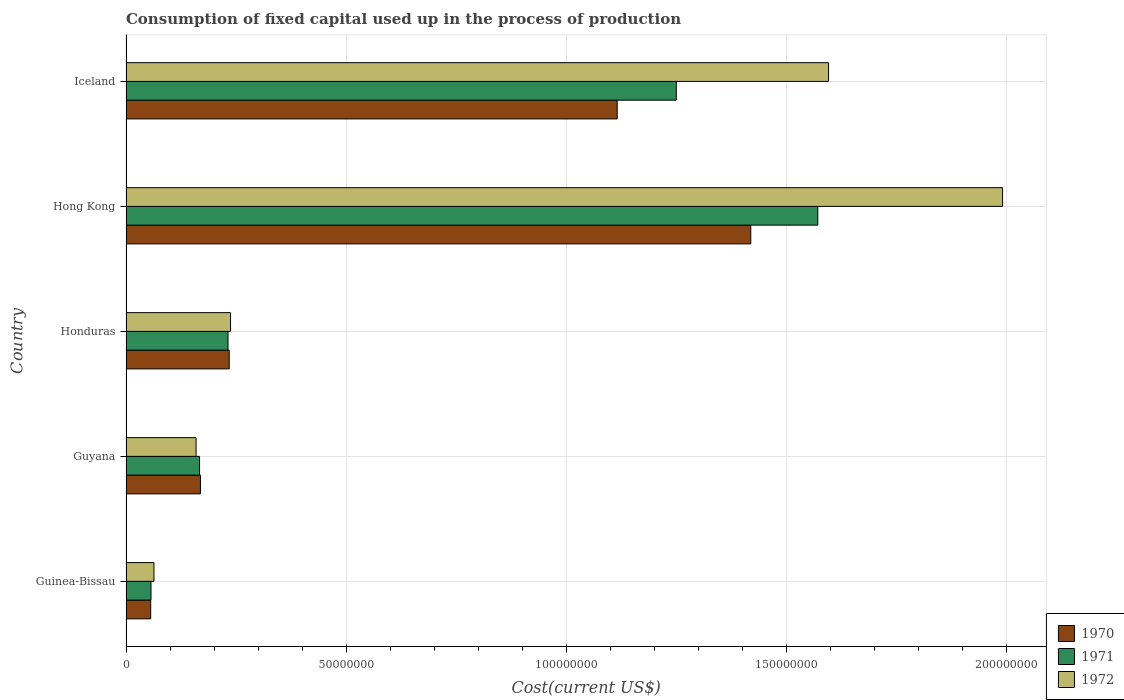How many groups of bars are there?
Your response must be concise. 5. Are the number of bars per tick equal to the number of legend labels?
Ensure brevity in your answer.  Yes. Are the number of bars on each tick of the Y-axis equal?
Give a very brief answer. Yes. How many bars are there on the 5th tick from the top?
Your answer should be compact. 3. What is the label of the 5th group of bars from the top?
Your answer should be very brief. Guinea-Bissau. What is the amount consumed in the process of production in 1972 in Guinea-Bissau?
Keep it short and to the point. 6.34e+06. Across all countries, what is the maximum amount consumed in the process of production in 1970?
Offer a very short reply. 1.42e+08. Across all countries, what is the minimum amount consumed in the process of production in 1972?
Offer a terse response. 6.34e+06. In which country was the amount consumed in the process of production in 1972 maximum?
Ensure brevity in your answer.  Hong Kong. In which country was the amount consumed in the process of production in 1971 minimum?
Offer a terse response. Guinea-Bissau. What is the total amount consumed in the process of production in 1970 in the graph?
Your response must be concise. 2.99e+08. What is the difference between the amount consumed in the process of production in 1970 in Honduras and that in Hong Kong?
Make the answer very short. -1.18e+08. What is the difference between the amount consumed in the process of production in 1972 in Hong Kong and the amount consumed in the process of production in 1970 in Iceland?
Your answer should be very brief. 8.75e+07. What is the average amount consumed in the process of production in 1970 per country?
Offer a very short reply. 5.99e+07. What is the difference between the amount consumed in the process of production in 1972 and amount consumed in the process of production in 1971 in Honduras?
Your answer should be very brief. 5.73e+05. What is the ratio of the amount consumed in the process of production in 1972 in Guinea-Bissau to that in Guyana?
Your response must be concise. 0.4. What is the difference between the highest and the second highest amount consumed in the process of production in 1970?
Provide a succinct answer. 3.03e+07. What is the difference between the highest and the lowest amount consumed in the process of production in 1970?
Offer a terse response. 1.36e+08. In how many countries, is the amount consumed in the process of production in 1971 greater than the average amount consumed in the process of production in 1971 taken over all countries?
Offer a terse response. 2. Is the sum of the amount consumed in the process of production in 1971 in Guyana and Iceland greater than the maximum amount consumed in the process of production in 1970 across all countries?
Give a very brief answer. No. What does the 1st bar from the bottom in Iceland represents?
Offer a terse response. 1970. Are all the bars in the graph horizontal?
Ensure brevity in your answer.  Yes. How many countries are there in the graph?
Your answer should be compact. 5. What is the difference between two consecutive major ticks on the X-axis?
Provide a succinct answer. 5.00e+07. Are the values on the major ticks of X-axis written in scientific E-notation?
Your answer should be very brief. No. Does the graph contain any zero values?
Make the answer very short. No. Does the graph contain grids?
Your response must be concise. Yes. Where does the legend appear in the graph?
Keep it short and to the point. Bottom right. How many legend labels are there?
Your answer should be very brief. 3. What is the title of the graph?
Your answer should be very brief. Consumption of fixed capital used up in the process of production. Does "1969" appear as one of the legend labels in the graph?
Provide a short and direct response. No. What is the label or title of the X-axis?
Your response must be concise. Cost(current US$). What is the Cost(current US$) of 1970 in Guinea-Bissau?
Provide a succinct answer. 5.61e+06. What is the Cost(current US$) of 1971 in Guinea-Bissau?
Make the answer very short. 5.67e+06. What is the Cost(current US$) in 1972 in Guinea-Bissau?
Provide a succinct answer. 6.34e+06. What is the Cost(current US$) of 1970 in Guyana?
Your answer should be compact. 1.69e+07. What is the Cost(current US$) of 1971 in Guyana?
Give a very brief answer. 1.67e+07. What is the Cost(current US$) of 1972 in Guyana?
Keep it short and to the point. 1.59e+07. What is the Cost(current US$) in 1970 in Honduras?
Ensure brevity in your answer.  2.34e+07. What is the Cost(current US$) in 1971 in Honduras?
Offer a very short reply. 2.32e+07. What is the Cost(current US$) in 1972 in Honduras?
Keep it short and to the point. 2.37e+07. What is the Cost(current US$) of 1970 in Hong Kong?
Offer a terse response. 1.42e+08. What is the Cost(current US$) in 1971 in Hong Kong?
Offer a very short reply. 1.57e+08. What is the Cost(current US$) in 1972 in Hong Kong?
Your answer should be very brief. 1.99e+08. What is the Cost(current US$) in 1970 in Iceland?
Provide a short and direct response. 1.12e+08. What is the Cost(current US$) in 1971 in Iceland?
Offer a very short reply. 1.25e+08. What is the Cost(current US$) of 1972 in Iceland?
Offer a very short reply. 1.60e+08. Across all countries, what is the maximum Cost(current US$) of 1970?
Your response must be concise. 1.42e+08. Across all countries, what is the maximum Cost(current US$) in 1971?
Your answer should be compact. 1.57e+08. Across all countries, what is the maximum Cost(current US$) of 1972?
Provide a succinct answer. 1.99e+08. Across all countries, what is the minimum Cost(current US$) in 1970?
Your response must be concise. 5.61e+06. Across all countries, what is the minimum Cost(current US$) of 1971?
Ensure brevity in your answer.  5.67e+06. Across all countries, what is the minimum Cost(current US$) in 1972?
Keep it short and to the point. 6.34e+06. What is the total Cost(current US$) of 1970 in the graph?
Your answer should be very brief. 2.99e+08. What is the total Cost(current US$) of 1971 in the graph?
Your answer should be compact. 3.28e+08. What is the total Cost(current US$) in 1972 in the graph?
Ensure brevity in your answer.  4.05e+08. What is the difference between the Cost(current US$) of 1970 in Guinea-Bissau and that in Guyana?
Offer a very short reply. -1.13e+07. What is the difference between the Cost(current US$) in 1971 in Guinea-Bissau and that in Guyana?
Ensure brevity in your answer.  -1.10e+07. What is the difference between the Cost(current US$) of 1972 in Guinea-Bissau and that in Guyana?
Make the answer very short. -9.56e+06. What is the difference between the Cost(current US$) in 1970 in Guinea-Bissau and that in Honduras?
Provide a short and direct response. -1.78e+07. What is the difference between the Cost(current US$) in 1971 in Guinea-Bissau and that in Honduras?
Your answer should be compact. -1.75e+07. What is the difference between the Cost(current US$) in 1972 in Guinea-Bissau and that in Honduras?
Ensure brevity in your answer.  -1.74e+07. What is the difference between the Cost(current US$) of 1970 in Guinea-Bissau and that in Hong Kong?
Provide a succinct answer. -1.36e+08. What is the difference between the Cost(current US$) of 1971 in Guinea-Bissau and that in Hong Kong?
Keep it short and to the point. -1.51e+08. What is the difference between the Cost(current US$) in 1972 in Guinea-Bissau and that in Hong Kong?
Your response must be concise. -1.93e+08. What is the difference between the Cost(current US$) of 1970 in Guinea-Bissau and that in Iceland?
Provide a short and direct response. -1.06e+08. What is the difference between the Cost(current US$) of 1971 in Guinea-Bissau and that in Iceland?
Your answer should be compact. -1.19e+08. What is the difference between the Cost(current US$) of 1972 in Guinea-Bissau and that in Iceland?
Give a very brief answer. -1.53e+08. What is the difference between the Cost(current US$) in 1970 in Guyana and that in Honduras?
Your answer should be compact. -6.54e+06. What is the difference between the Cost(current US$) in 1971 in Guyana and that in Honduras?
Make the answer very short. -6.46e+06. What is the difference between the Cost(current US$) in 1972 in Guyana and that in Honduras?
Give a very brief answer. -7.83e+06. What is the difference between the Cost(current US$) of 1970 in Guyana and that in Hong Kong?
Give a very brief answer. -1.25e+08. What is the difference between the Cost(current US$) in 1971 in Guyana and that in Hong Kong?
Offer a very short reply. -1.40e+08. What is the difference between the Cost(current US$) in 1972 in Guyana and that in Hong Kong?
Your response must be concise. -1.83e+08. What is the difference between the Cost(current US$) in 1970 in Guyana and that in Iceland?
Your answer should be compact. -9.46e+07. What is the difference between the Cost(current US$) in 1971 in Guyana and that in Iceland?
Offer a terse response. -1.08e+08. What is the difference between the Cost(current US$) of 1972 in Guyana and that in Iceland?
Provide a succinct answer. -1.44e+08. What is the difference between the Cost(current US$) of 1970 in Honduras and that in Hong Kong?
Provide a succinct answer. -1.18e+08. What is the difference between the Cost(current US$) in 1971 in Honduras and that in Hong Kong?
Your answer should be very brief. -1.34e+08. What is the difference between the Cost(current US$) of 1972 in Honduras and that in Hong Kong?
Offer a very short reply. -1.75e+08. What is the difference between the Cost(current US$) of 1970 in Honduras and that in Iceland?
Make the answer very short. -8.81e+07. What is the difference between the Cost(current US$) in 1971 in Honduras and that in Iceland?
Offer a terse response. -1.02e+08. What is the difference between the Cost(current US$) of 1972 in Honduras and that in Iceland?
Give a very brief answer. -1.36e+08. What is the difference between the Cost(current US$) in 1970 in Hong Kong and that in Iceland?
Provide a succinct answer. 3.03e+07. What is the difference between the Cost(current US$) of 1971 in Hong Kong and that in Iceland?
Your response must be concise. 3.21e+07. What is the difference between the Cost(current US$) in 1972 in Hong Kong and that in Iceland?
Provide a succinct answer. 3.95e+07. What is the difference between the Cost(current US$) of 1970 in Guinea-Bissau and the Cost(current US$) of 1971 in Guyana?
Keep it short and to the point. -1.11e+07. What is the difference between the Cost(current US$) of 1970 in Guinea-Bissau and the Cost(current US$) of 1972 in Guyana?
Ensure brevity in your answer.  -1.03e+07. What is the difference between the Cost(current US$) in 1971 in Guinea-Bissau and the Cost(current US$) in 1972 in Guyana?
Make the answer very short. -1.02e+07. What is the difference between the Cost(current US$) of 1970 in Guinea-Bissau and the Cost(current US$) of 1971 in Honduras?
Your answer should be compact. -1.76e+07. What is the difference between the Cost(current US$) in 1970 in Guinea-Bissau and the Cost(current US$) in 1972 in Honduras?
Ensure brevity in your answer.  -1.81e+07. What is the difference between the Cost(current US$) of 1971 in Guinea-Bissau and the Cost(current US$) of 1972 in Honduras?
Your answer should be compact. -1.81e+07. What is the difference between the Cost(current US$) of 1970 in Guinea-Bissau and the Cost(current US$) of 1971 in Hong Kong?
Keep it short and to the point. -1.51e+08. What is the difference between the Cost(current US$) in 1970 in Guinea-Bissau and the Cost(current US$) in 1972 in Hong Kong?
Provide a short and direct response. -1.93e+08. What is the difference between the Cost(current US$) in 1971 in Guinea-Bissau and the Cost(current US$) in 1972 in Hong Kong?
Keep it short and to the point. -1.93e+08. What is the difference between the Cost(current US$) of 1970 in Guinea-Bissau and the Cost(current US$) of 1971 in Iceland?
Your response must be concise. -1.19e+08. What is the difference between the Cost(current US$) of 1970 in Guinea-Bissau and the Cost(current US$) of 1972 in Iceland?
Offer a terse response. -1.54e+08. What is the difference between the Cost(current US$) of 1971 in Guinea-Bissau and the Cost(current US$) of 1972 in Iceland?
Ensure brevity in your answer.  -1.54e+08. What is the difference between the Cost(current US$) of 1970 in Guyana and the Cost(current US$) of 1971 in Honduras?
Give a very brief answer. -6.26e+06. What is the difference between the Cost(current US$) in 1970 in Guyana and the Cost(current US$) in 1972 in Honduras?
Ensure brevity in your answer.  -6.83e+06. What is the difference between the Cost(current US$) in 1971 in Guyana and the Cost(current US$) in 1972 in Honduras?
Your response must be concise. -7.03e+06. What is the difference between the Cost(current US$) of 1970 in Guyana and the Cost(current US$) of 1971 in Hong Kong?
Provide a succinct answer. -1.40e+08. What is the difference between the Cost(current US$) in 1970 in Guyana and the Cost(current US$) in 1972 in Hong Kong?
Your answer should be compact. -1.82e+08. What is the difference between the Cost(current US$) in 1971 in Guyana and the Cost(current US$) in 1972 in Hong Kong?
Offer a very short reply. -1.82e+08. What is the difference between the Cost(current US$) in 1970 in Guyana and the Cost(current US$) in 1971 in Iceland?
Keep it short and to the point. -1.08e+08. What is the difference between the Cost(current US$) in 1970 in Guyana and the Cost(current US$) in 1972 in Iceland?
Give a very brief answer. -1.43e+08. What is the difference between the Cost(current US$) in 1971 in Guyana and the Cost(current US$) in 1972 in Iceland?
Your answer should be compact. -1.43e+08. What is the difference between the Cost(current US$) in 1970 in Honduras and the Cost(current US$) in 1971 in Hong Kong?
Make the answer very short. -1.34e+08. What is the difference between the Cost(current US$) of 1970 in Honduras and the Cost(current US$) of 1972 in Hong Kong?
Keep it short and to the point. -1.76e+08. What is the difference between the Cost(current US$) of 1971 in Honduras and the Cost(current US$) of 1972 in Hong Kong?
Provide a short and direct response. -1.76e+08. What is the difference between the Cost(current US$) of 1970 in Honduras and the Cost(current US$) of 1971 in Iceland?
Your answer should be compact. -1.02e+08. What is the difference between the Cost(current US$) in 1970 in Honduras and the Cost(current US$) in 1972 in Iceland?
Provide a succinct answer. -1.36e+08. What is the difference between the Cost(current US$) in 1971 in Honduras and the Cost(current US$) in 1972 in Iceland?
Provide a succinct answer. -1.36e+08. What is the difference between the Cost(current US$) in 1970 in Hong Kong and the Cost(current US$) in 1971 in Iceland?
Make the answer very short. 1.69e+07. What is the difference between the Cost(current US$) of 1970 in Hong Kong and the Cost(current US$) of 1972 in Iceland?
Your response must be concise. -1.77e+07. What is the difference between the Cost(current US$) of 1971 in Hong Kong and the Cost(current US$) of 1972 in Iceland?
Give a very brief answer. -2.45e+06. What is the average Cost(current US$) in 1970 per country?
Provide a succinct answer. 5.99e+07. What is the average Cost(current US$) in 1971 per country?
Your answer should be very brief. 6.55e+07. What is the average Cost(current US$) of 1972 per country?
Offer a terse response. 8.09e+07. What is the difference between the Cost(current US$) of 1970 and Cost(current US$) of 1971 in Guinea-Bissau?
Keep it short and to the point. -6.59e+04. What is the difference between the Cost(current US$) in 1970 and Cost(current US$) in 1972 in Guinea-Bissau?
Provide a succinct answer. -7.37e+05. What is the difference between the Cost(current US$) in 1971 and Cost(current US$) in 1972 in Guinea-Bissau?
Keep it short and to the point. -6.71e+05. What is the difference between the Cost(current US$) of 1970 and Cost(current US$) of 1972 in Guyana?
Provide a short and direct response. 9.95e+05. What is the difference between the Cost(current US$) in 1971 and Cost(current US$) in 1972 in Guyana?
Keep it short and to the point. 7.95e+05. What is the difference between the Cost(current US$) in 1970 and Cost(current US$) in 1971 in Honduras?
Ensure brevity in your answer.  2.75e+05. What is the difference between the Cost(current US$) of 1970 and Cost(current US$) of 1972 in Honduras?
Make the answer very short. -2.98e+05. What is the difference between the Cost(current US$) in 1971 and Cost(current US$) in 1972 in Honduras?
Make the answer very short. -5.73e+05. What is the difference between the Cost(current US$) of 1970 and Cost(current US$) of 1971 in Hong Kong?
Provide a succinct answer. -1.52e+07. What is the difference between the Cost(current US$) of 1970 and Cost(current US$) of 1972 in Hong Kong?
Offer a very short reply. -5.72e+07. What is the difference between the Cost(current US$) of 1971 and Cost(current US$) of 1972 in Hong Kong?
Your answer should be very brief. -4.20e+07. What is the difference between the Cost(current US$) of 1970 and Cost(current US$) of 1971 in Iceland?
Provide a short and direct response. -1.34e+07. What is the difference between the Cost(current US$) in 1970 and Cost(current US$) in 1972 in Iceland?
Keep it short and to the point. -4.80e+07. What is the difference between the Cost(current US$) in 1971 and Cost(current US$) in 1972 in Iceland?
Provide a short and direct response. -3.46e+07. What is the ratio of the Cost(current US$) of 1970 in Guinea-Bissau to that in Guyana?
Ensure brevity in your answer.  0.33. What is the ratio of the Cost(current US$) in 1971 in Guinea-Bissau to that in Guyana?
Your answer should be compact. 0.34. What is the ratio of the Cost(current US$) of 1972 in Guinea-Bissau to that in Guyana?
Your answer should be very brief. 0.4. What is the ratio of the Cost(current US$) of 1970 in Guinea-Bissau to that in Honduras?
Keep it short and to the point. 0.24. What is the ratio of the Cost(current US$) of 1971 in Guinea-Bissau to that in Honduras?
Offer a terse response. 0.24. What is the ratio of the Cost(current US$) in 1972 in Guinea-Bissau to that in Honduras?
Your answer should be very brief. 0.27. What is the ratio of the Cost(current US$) of 1970 in Guinea-Bissau to that in Hong Kong?
Keep it short and to the point. 0.04. What is the ratio of the Cost(current US$) of 1971 in Guinea-Bissau to that in Hong Kong?
Ensure brevity in your answer.  0.04. What is the ratio of the Cost(current US$) in 1972 in Guinea-Bissau to that in Hong Kong?
Provide a short and direct response. 0.03. What is the ratio of the Cost(current US$) of 1970 in Guinea-Bissau to that in Iceland?
Provide a succinct answer. 0.05. What is the ratio of the Cost(current US$) in 1971 in Guinea-Bissau to that in Iceland?
Keep it short and to the point. 0.05. What is the ratio of the Cost(current US$) in 1972 in Guinea-Bissau to that in Iceland?
Give a very brief answer. 0.04. What is the ratio of the Cost(current US$) in 1970 in Guyana to that in Honduras?
Make the answer very short. 0.72. What is the ratio of the Cost(current US$) of 1971 in Guyana to that in Honduras?
Keep it short and to the point. 0.72. What is the ratio of the Cost(current US$) of 1972 in Guyana to that in Honduras?
Provide a succinct answer. 0.67. What is the ratio of the Cost(current US$) of 1970 in Guyana to that in Hong Kong?
Offer a terse response. 0.12. What is the ratio of the Cost(current US$) of 1971 in Guyana to that in Hong Kong?
Offer a very short reply. 0.11. What is the ratio of the Cost(current US$) in 1972 in Guyana to that in Hong Kong?
Your answer should be compact. 0.08. What is the ratio of the Cost(current US$) of 1970 in Guyana to that in Iceland?
Offer a terse response. 0.15. What is the ratio of the Cost(current US$) in 1971 in Guyana to that in Iceland?
Offer a terse response. 0.13. What is the ratio of the Cost(current US$) in 1972 in Guyana to that in Iceland?
Ensure brevity in your answer.  0.1. What is the ratio of the Cost(current US$) of 1970 in Honduras to that in Hong Kong?
Your answer should be compact. 0.17. What is the ratio of the Cost(current US$) in 1971 in Honduras to that in Hong Kong?
Provide a short and direct response. 0.15. What is the ratio of the Cost(current US$) in 1972 in Honduras to that in Hong Kong?
Ensure brevity in your answer.  0.12. What is the ratio of the Cost(current US$) in 1970 in Honduras to that in Iceland?
Your answer should be compact. 0.21. What is the ratio of the Cost(current US$) in 1971 in Honduras to that in Iceland?
Make the answer very short. 0.19. What is the ratio of the Cost(current US$) of 1972 in Honduras to that in Iceland?
Offer a terse response. 0.15. What is the ratio of the Cost(current US$) in 1970 in Hong Kong to that in Iceland?
Provide a short and direct response. 1.27. What is the ratio of the Cost(current US$) of 1971 in Hong Kong to that in Iceland?
Your response must be concise. 1.26. What is the ratio of the Cost(current US$) of 1972 in Hong Kong to that in Iceland?
Provide a succinct answer. 1.25. What is the difference between the highest and the second highest Cost(current US$) of 1970?
Your response must be concise. 3.03e+07. What is the difference between the highest and the second highest Cost(current US$) in 1971?
Make the answer very short. 3.21e+07. What is the difference between the highest and the second highest Cost(current US$) in 1972?
Your answer should be very brief. 3.95e+07. What is the difference between the highest and the lowest Cost(current US$) in 1970?
Your answer should be very brief. 1.36e+08. What is the difference between the highest and the lowest Cost(current US$) of 1971?
Provide a short and direct response. 1.51e+08. What is the difference between the highest and the lowest Cost(current US$) in 1972?
Provide a succinct answer. 1.93e+08. 